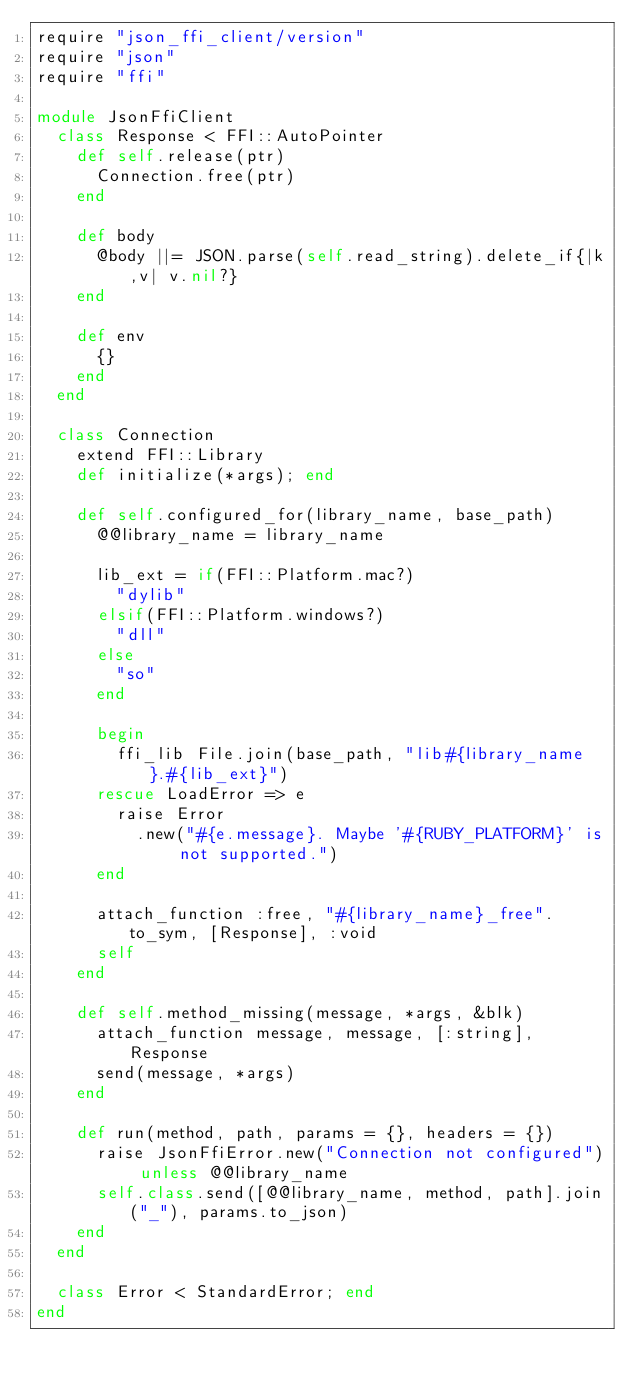<code> <loc_0><loc_0><loc_500><loc_500><_Ruby_>require "json_ffi_client/version"
require "json"
require "ffi"

module JsonFfiClient
  class Response < FFI::AutoPointer
    def self.release(ptr)
      Connection.free(ptr)
    end

    def body
      @body ||= JSON.parse(self.read_string).delete_if{|k,v| v.nil?}
    end
    
    def env
      {}
    end
  end

  class Connection
    extend FFI::Library
    def initialize(*args); end

    def self.configured_for(library_name, base_path)
      @@library_name = library_name

      lib_ext = if(FFI::Platform.mac?)
        "dylib"
      elsif(FFI::Platform.windows?)
        "dll"
      else
        "so"
      end

      begin 
        ffi_lib File.join(base_path, "lib#{library_name}.#{lib_ext}")
      rescue LoadError => e
        raise Error
          .new("#{e.message}. Maybe '#{RUBY_PLATFORM}' is not supported.")
      end

      attach_function :free, "#{library_name}_free".to_sym, [Response], :void
      self
    end
    
    def self.method_missing(message, *args, &blk)
      attach_function message, message, [:string], Response
      send(message, *args)
    end
    
    def run(method, path, params = {}, headers = {})
      raise JsonFfiError.new("Connection not configured") unless @@library_name
      self.class.send([@@library_name, method, path].join("_"), params.to_json)
    end
  end

  class Error < StandardError; end
end
</code> 